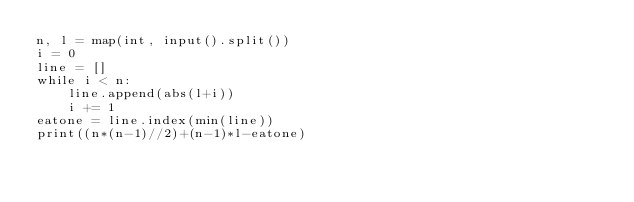<code> <loc_0><loc_0><loc_500><loc_500><_Python_>n, l = map(int, input().split())
i = 0
line = []
while i < n:
    line.append(abs(l+i))
    i += 1
eatone = line.index(min(line))
print((n*(n-1)//2)+(n-1)*l-eatone)</code> 